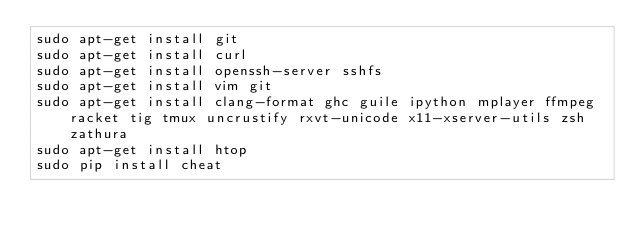<code> <loc_0><loc_0><loc_500><loc_500><_Bash_>sudo apt-get install git
sudo apt-get install curl
sudo apt-get install openssh-server sshfs
sudo apt-get install vim git
sudo apt-get install clang-format ghc guile ipython mplayer ffmpeg racket tig tmux uncrustify rxvt-unicode x11-xserver-utils zsh zathura
sudo apt-get install htop
sudo pip install cheat
</code> 